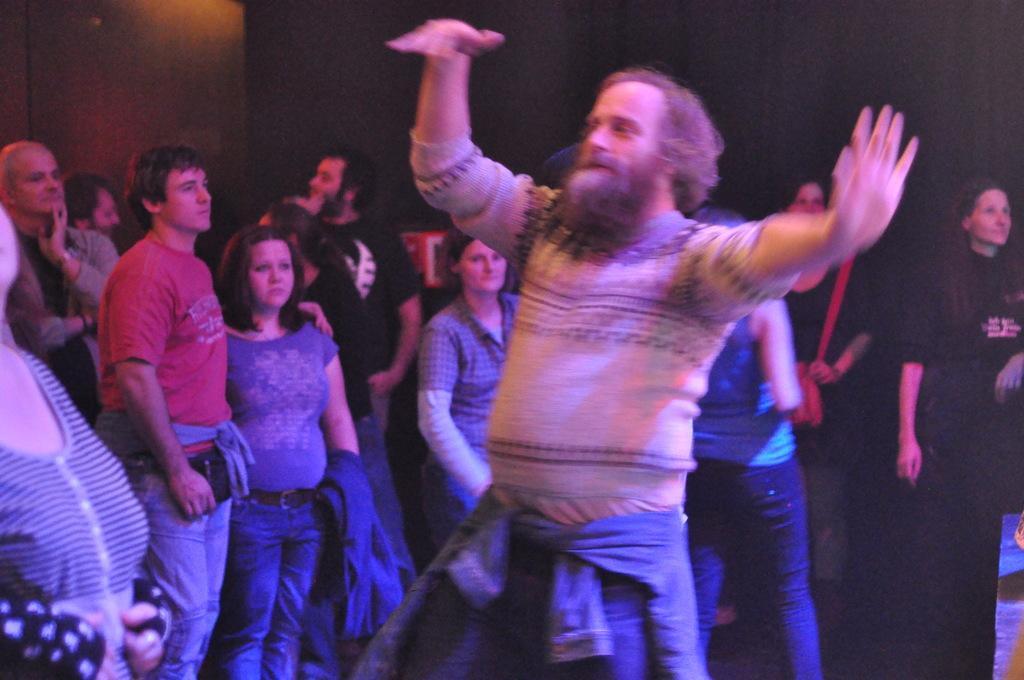Can you describe this image briefly? In this picture I can see in the middle a man is dancing, in the background a group of people are standing and looking at the right side. 